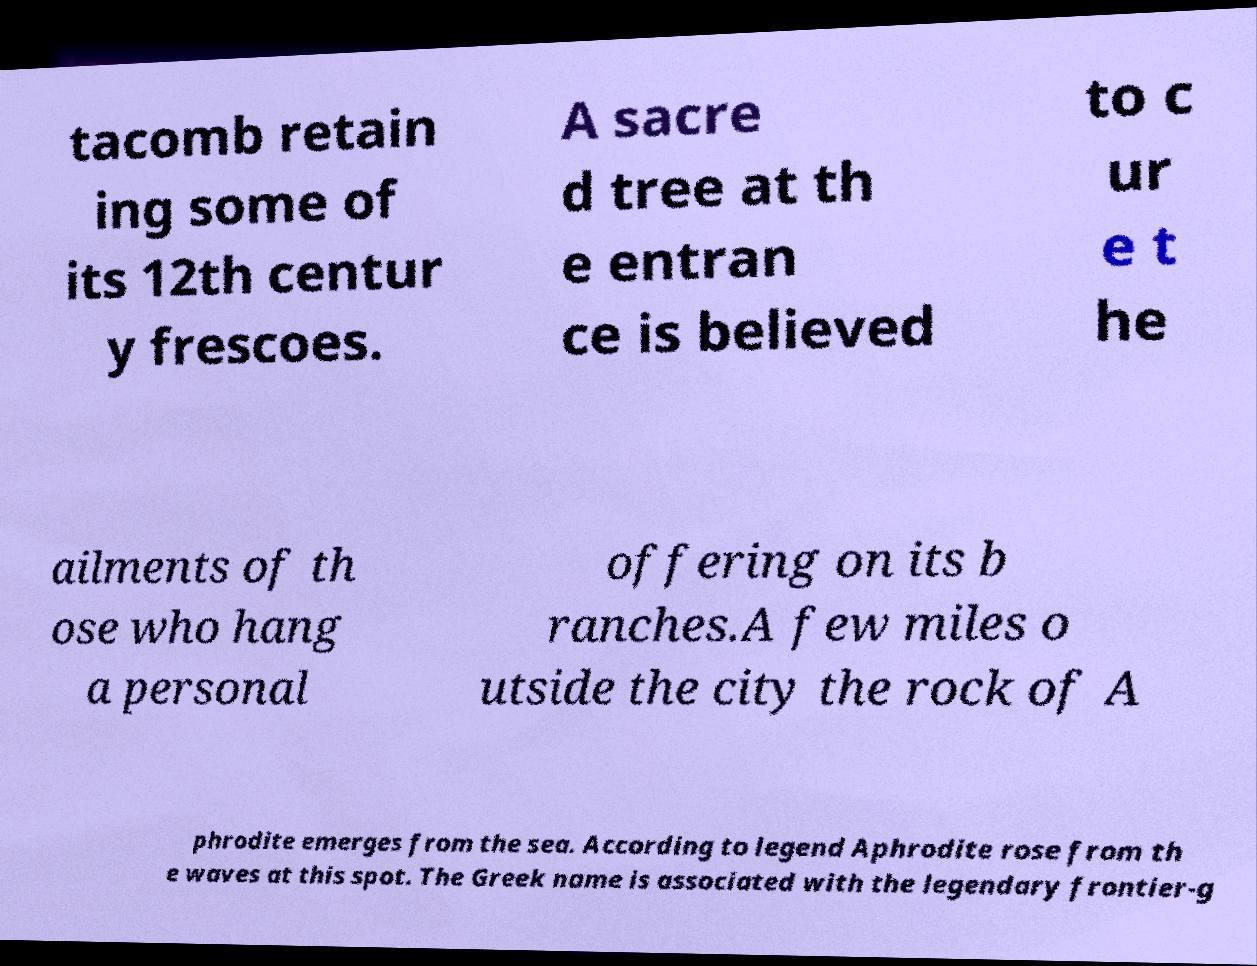Can you read and provide the text displayed in the image?This photo seems to have some interesting text. Can you extract and type it out for me? tacomb retain ing some of its 12th centur y frescoes. A sacre d tree at th e entran ce is believed to c ur e t he ailments of th ose who hang a personal offering on its b ranches.A few miles o utside the city the rock of A phrodite emerges from the sea. According to legend Aphrodite rose from th e waves at this spot. The Greek name is associated with the legendary frontier-g 